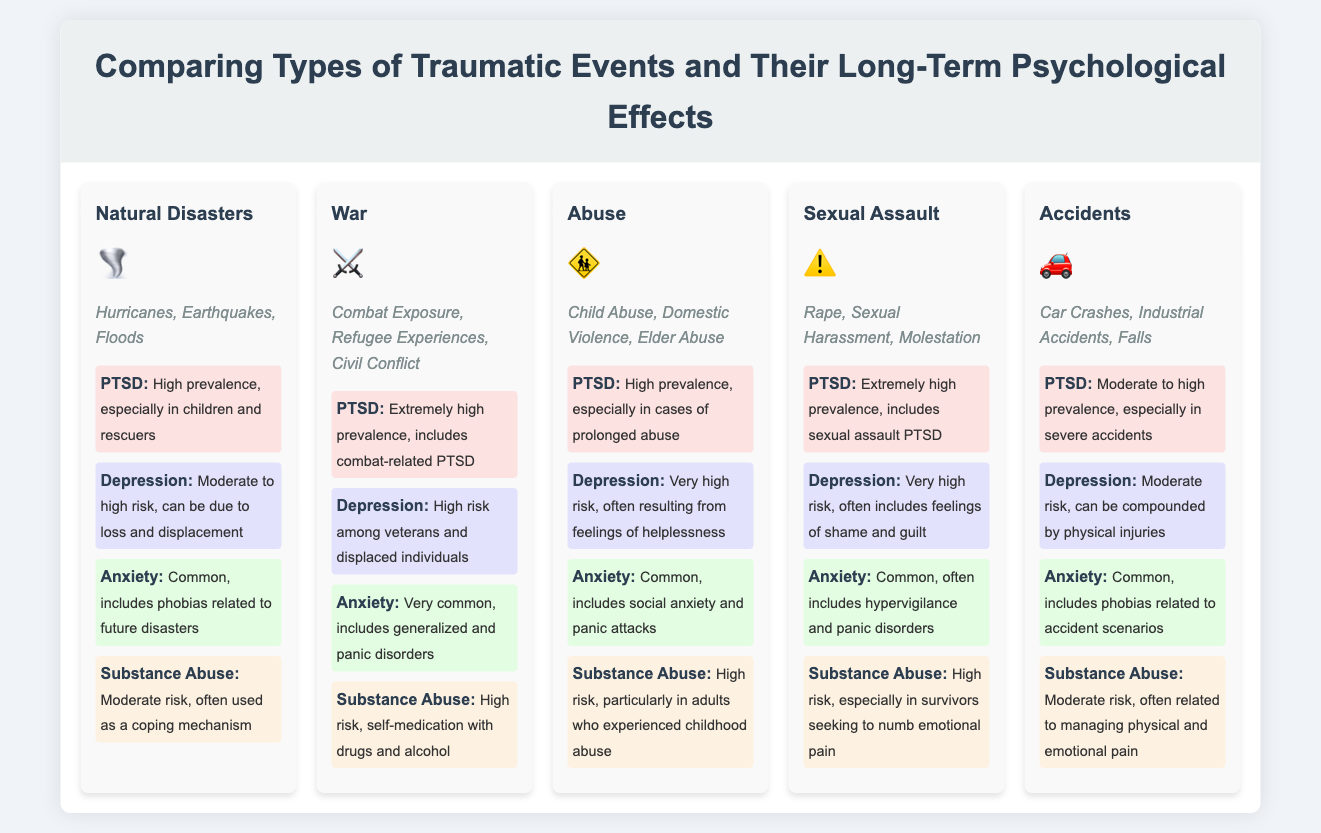What is an example of a natural disaster? The document lists hurricanes, earthquakes, and floods as examples of natural disasters.
Answer: Hurricanes Which type of traumatic event has the highest PTSD prevalence? The document states that war and sexual assault have extremely high prevalence of PTSD.
Answer: War What color represents anxiety effects in the infographic? The document uses a light green color to highlight anxiety effects.
Answer: Light green What is the effect of child abuse on depression risk? The document mentions that depression has a very high risk for individuals who experienced child abuse.
Answer: Very high risk Which type of traumatic event has a moderate risk of substance abuse? The document indicates that accidents carry a moderate risk of substance abuse.
Answer: Accidents What psychological effect is common in survivors of sexual assault? The document states that anxiety is common among survivors of sexual assault.
Answer: Anxiety How does the prevalence of PTSD in natural disasters compare to accidents? The document outlines that natural disasters have a high prevalence of PTSD while accidents have a moderate to high prevalence.
Answer: High vs. Moderate to high Which traumatic event example includes combat exposure? The document categorizes war events that include combat exposure.
Answer: War 